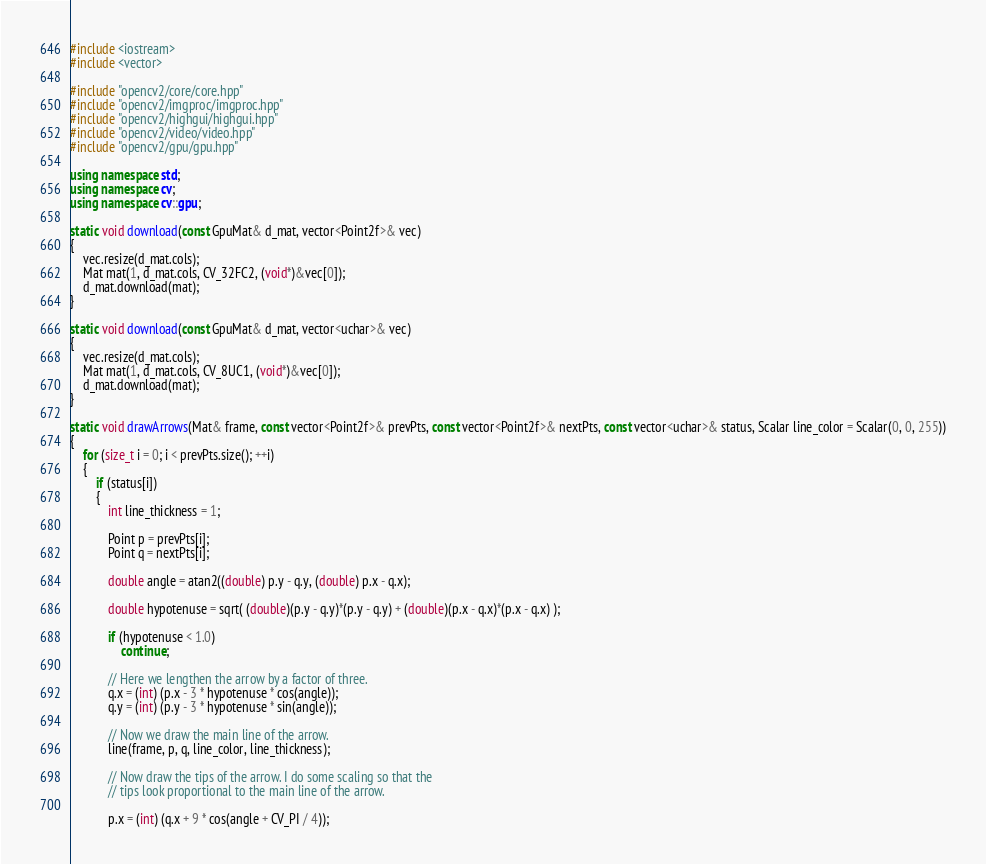<code> <loc_0><loc_0><loc_500><loc_500><_C++_>#include <iostream>
#include <vector>

#include "opencv2/core/core.hpp"
#include "opencv2/imgproc/imgproc.hpp"
#include "opencv2/highgui/highgui.hpp"
#include "opencv2/video/video.hpp"
#include "opencv2/gpu/gpu.hpp"

using namespace std;
using namespace cv;
using namespace cv::gpu;

static void download(const GpuMat& d_mat, vector<Point2f>& vec)
{
    vec.resize(d_mat.cols);
    Mat mat(1, d_mat.cols, CV_32FC2, (void*)&vec[0]);
    d_mat.download(mat);
}

static void download(const GpuMat& d_mat, vector<uchar>& vec)
{
    vec.resize(d_mat.cols);
    Mat mat(1, d_mat.cols, CV_8UC1, (void*)&vec[0]);
    d_mat.download(mat);
}

static void drawArrows(Mat& frame, const vector<Point2f>& prevPts, const vector<Point2f>& nextPts, const vector<uchar>& status, Scalar line_color = Scalar(0, 0, 255))
{
    for (size_t i = 0; i < prevPts.size(); ++i)
    {
        if (status[i])
        {
            int line_thickness = 1;

            Point p = prevPts[i];
            Point q = nextPts[i];

            double angle = atan2((double) p.y - q.y, (double) p.x - q.x);

            double hypotenuse = sqrt( (double)(p.y - q.y)*(p.y - q.y) + (double)(p.x - q.x)*(p.x - q.x) );

            if (hypotenuse < 1.0)
                continue;

            // Here we lengthen the arrow by a factor of three.
            q.x = (int) (p.x - 3 * hypotenuse * cos(angle));
            q.y = (int) (p.y - 3 * hypotenuse * sin(angle));

            // Now we draw the main line of the arrow.
            line(frame, p, q, line_color, line_thickness);

            // Now draw the tips of the arrow. I do some scaling so that the
            // tips look proportional to the main line of the arrow.

            p.x = (int) (q.x + 9 * cos(angle + CV_PI / 4));</code> 